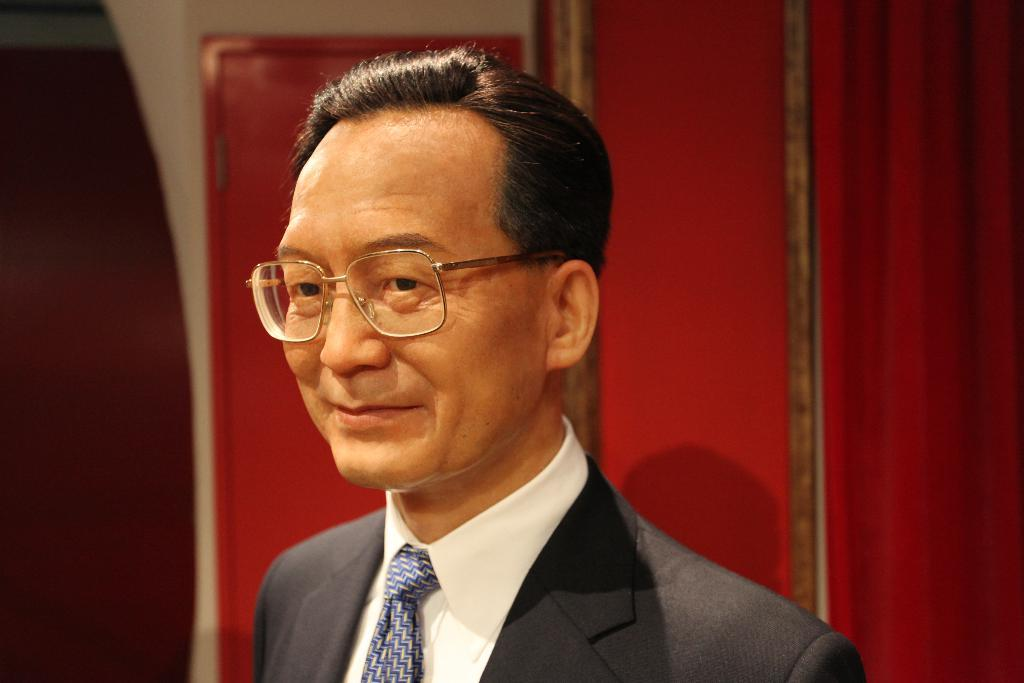Who or what is present in the image? There is a person in the image. What is the person wearing around their neck? The person is wearing a tie. What type of eyewear is the person wearing? The person is wearing spectacles. What verse is being recited by the person in the image? There is no indication in the image that the person is reciting a verse, so it cannot be determined from the picture. 